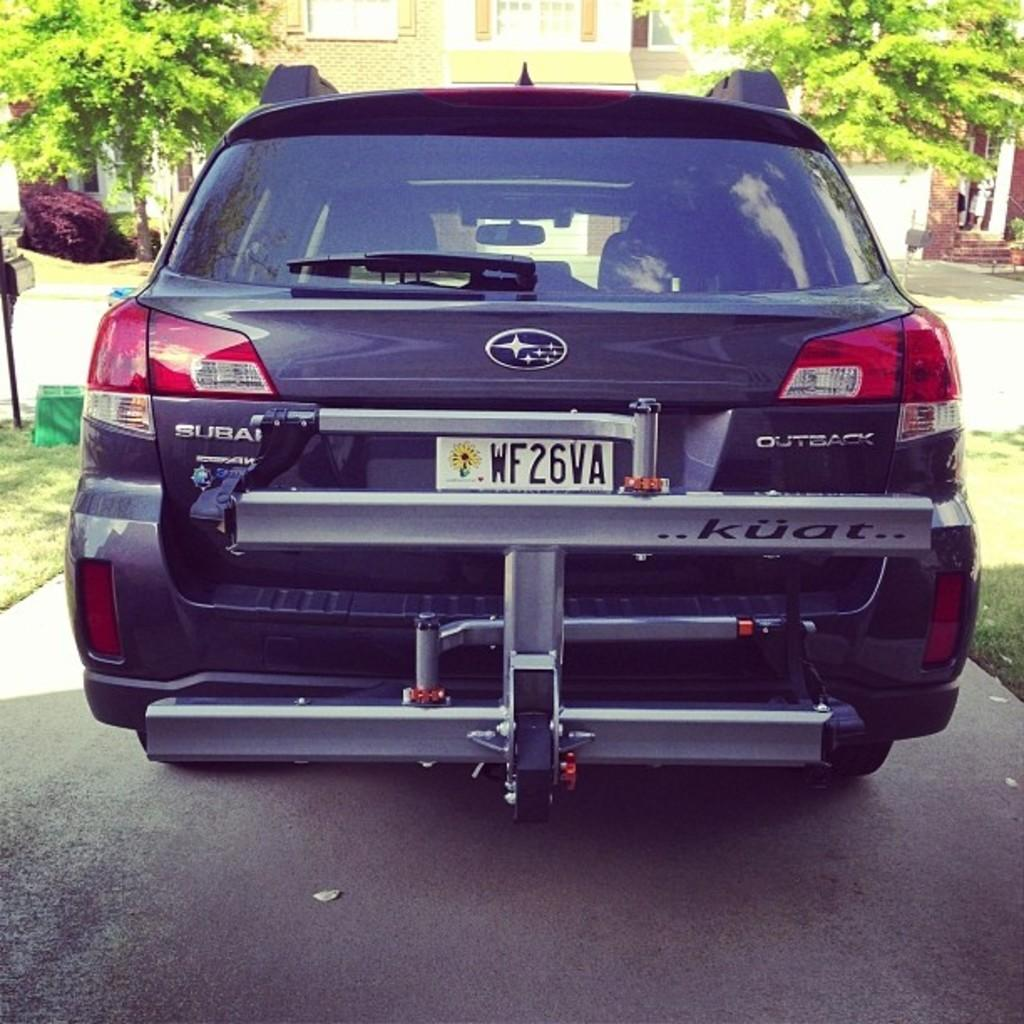<image>
Provide a brief description of the given image. a license plate that has wf2 on it 